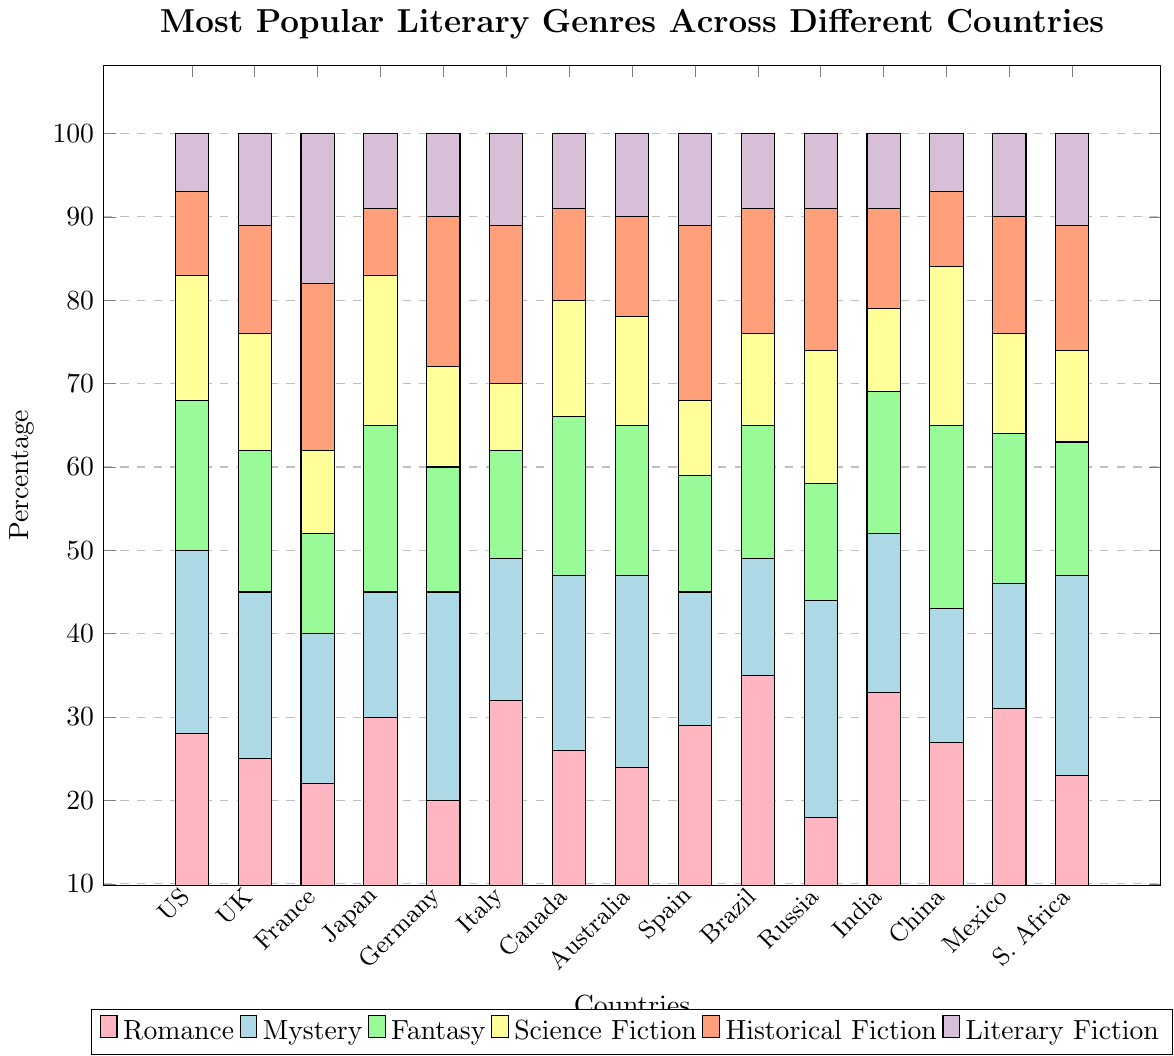Which country has the highest percentage of readers who prefer Romance? To identify the country with the highest percentage of Romance readers, locate the tallest bar segment of the color corresponding to Romance (pink) on the plot. Brazil has the tallest pink bar segment.
Answer: Brazil Which literary genre is most popular in France? Look at the height of different colored bar segments within the France bar. The tallest segment in France's bar is the one for Historical Fiction (orange).
Answer: Historical Fiction What is the total percentage of readers in Germany who prefer either Mystery or Historical Fiction? Find the heights of the Mystery (light blue) and Historical Fiction (orange) segments in Germany's bar. Add these values: 25 (Mystery) + 18 (Historical Fiction) = 43.
Answer: 43 Which country has a higher percentage of readers who prefer Science Fiction, Japan or South Africa? Compare the Science Fiction bar segments (yellow) for Japan and South Africa. Japan's segment is taller at 18%, while South Africa's is at 11%.
Answer: Japan What is the difference in percentage of readers who prefer Fantasy between China and India? Compare the Fantasy bar segments (light green) for China and India. China has 22%, while India has 17%. The difference is 22 - 17 = 5.
Answer: 5 In which country does Literary Fiction have the smallest share among readers? Identify the smallest Literary Fiction bar segment (purple) across all countries. The United States and China both have the smallest segment at 7%.
Answer: United States and China What is the average percentage of Romance readers in the United States, Canada, and Australia? Add the percentages of Romance readers in these countries and then divide by the number of countries: (28 + 26 + 24) / 3 = 26.
Answer: 26 Which genre is overall least popular in Russia? Look at Russia's bar and identify the shortest segment. Literary Fiction (purple) is the shortest at 9%.
Answer: Literary Fiction How does the popularity of Mystery compare between the United Kingdom and Brazil? Compare the Mystery bar segments (light blue) of the United Kingdom and Brazil. The UK’s segment is 20%, while Brazil’s is 14%.
Answer: UK > % Which three countries have the highest percentage of readers who prefer Literary Fiction? Identify the tallest Literary Fiction (purple) bar segments. France (18%), United Kingdom (11%), Italy, Spain, and South Africa (11%) have the tallest segments.
Answer: France, United Kingdom, Italy, Spain, South Africa 